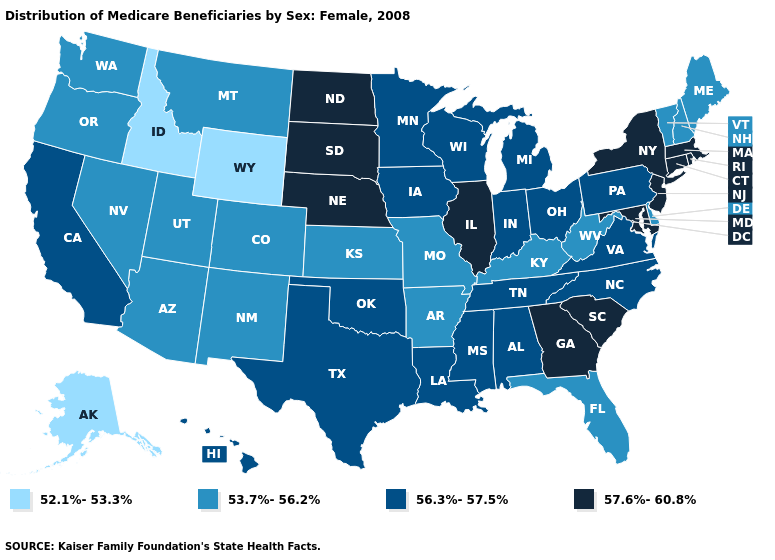How many symbols are there in the legend?
Short answer required. 4. What is the lowest value in the West?
Quick response, please. 52.1%-53.3%. Among the states that border Kentucky , does Illinois have the highest value?
Quick response, please. Yes. Does the first symbol in the legend represent the smallest category?
Give a very brief answer. Yes. Which states have the lowest value in the MidWest?
Quick response, please. Kansas, Missouri. Does Kentucky have a higher value than Rhode Island?
Keep it brief. No. What is the value of Rhode Island?
Be succinct. 57.6%-60.8%. What is the value of New York?
Keep it brief. 57.6%-60.8%. What is the value of New York?
Give a very brief answer. 57.6%-60.8%. Which states have the lowest value in the USA?
Give a very brief answer. Alaska, Idaho, Wyoming. Name the states that have a value in the range 52.1%-53.3%?
Quick response, please. Alaska, Idaho, Wyoming. What is the value of Michigan?
Answer briefly. 56.3%-57.5%. Does Idaho have the lowest value in the USA?
Quick response, please. Yes. Name the states that have a value in the range 52.1%-53.3%?
Write a very short answer. Alaska, Idaho, Wyoming. What is the highest value in the Northeast ?
Keep it brief. 57.6%-60.8%. 